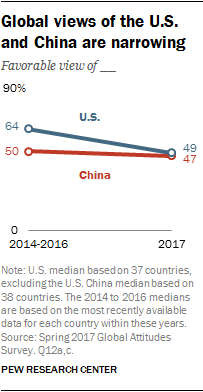Identify some key points in this picture. The chart compares the GDP per capita of the United States and China, two countries that are being compared in the chart. The maximum value of the blue line is 64. 